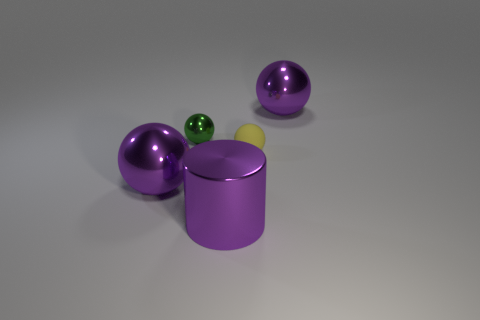Subtract all metal spheres. How many spheres are left? 1 Subtract all yellow balls. How many balls are left? 3 Subtract all cylinders. How many objects are left? 4 Subtract 1 cylinders. How many cylinders are left? 0 Add 2 tiny matte spheres. How many objects exist? 7 Subtract all yellow cylinders. How many purple spheres are left? 2 Subtract all red shiny balls. Subtract all yellow rubber spheres. How many objects are left? 4 Add 3 small green things. How many small green things are left? 4 Add 1 tiny matte spheres. How many tiny matte spheres exist? 2 Subtract 0 cyan balls. How many objects are left? 5 